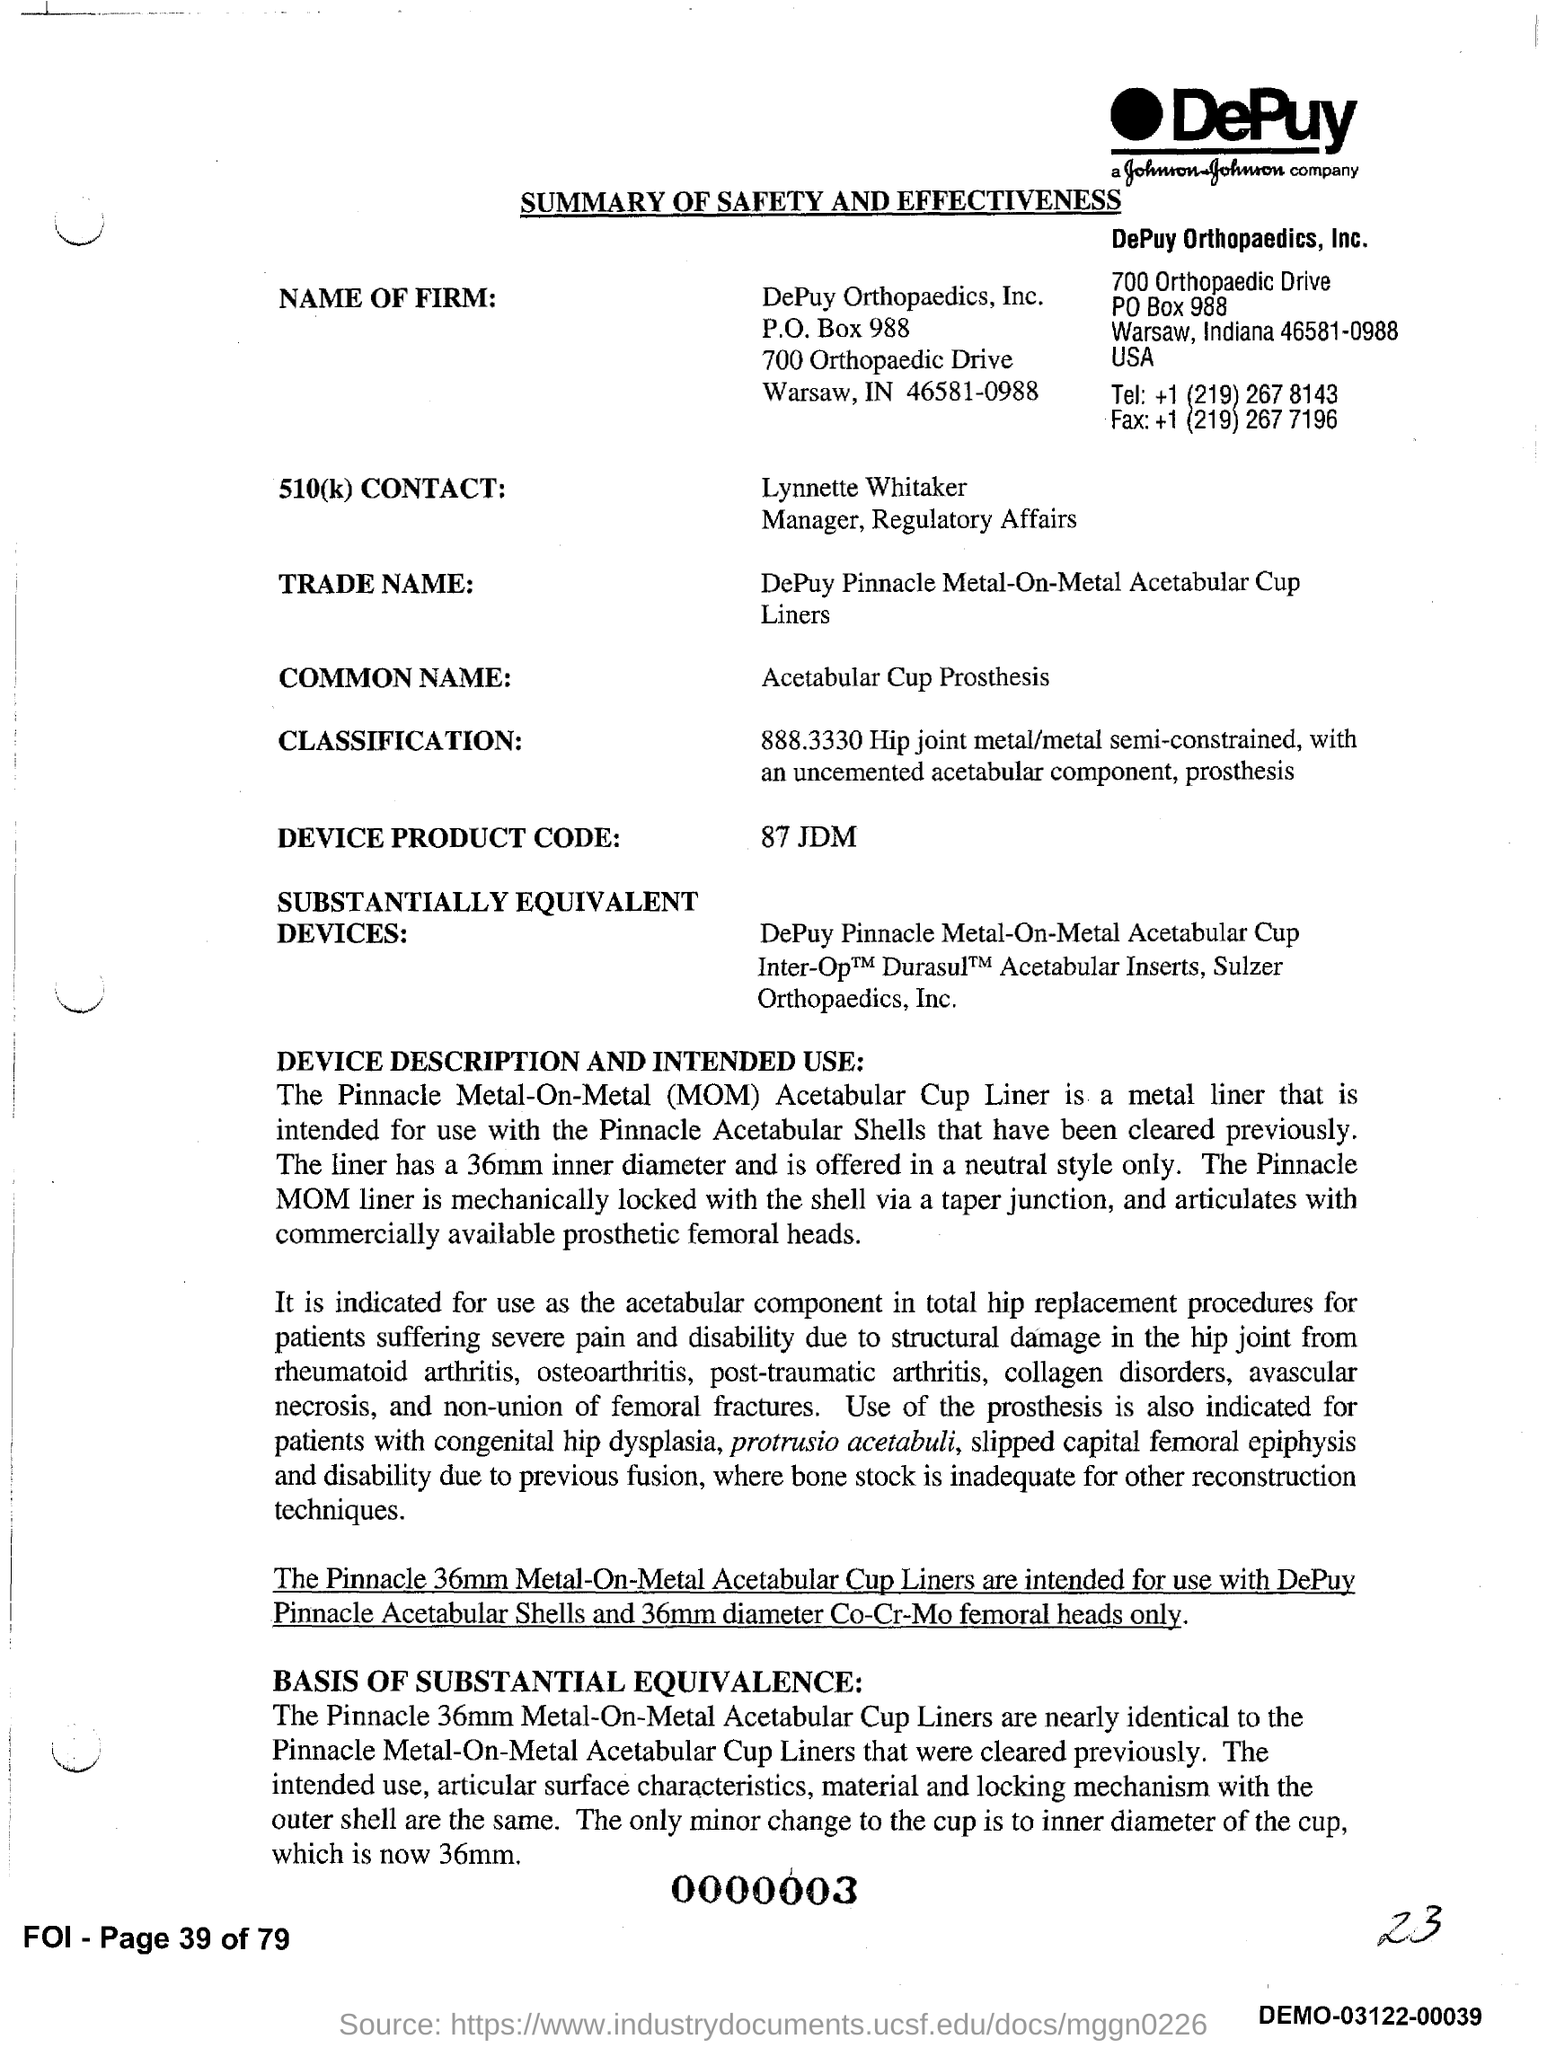Mention a couple of crucial points in this snapshot. The document title is a summary of the safety and effectiveness of [insert content]. The device product code is 87 JDM. DePuy Orthopaedics, Inc., is the name of the firm. The common name of the product is the Acetabular Cup Prosthesis. Lynnette Whitaker is the Manager of Regulatory Affairs. 